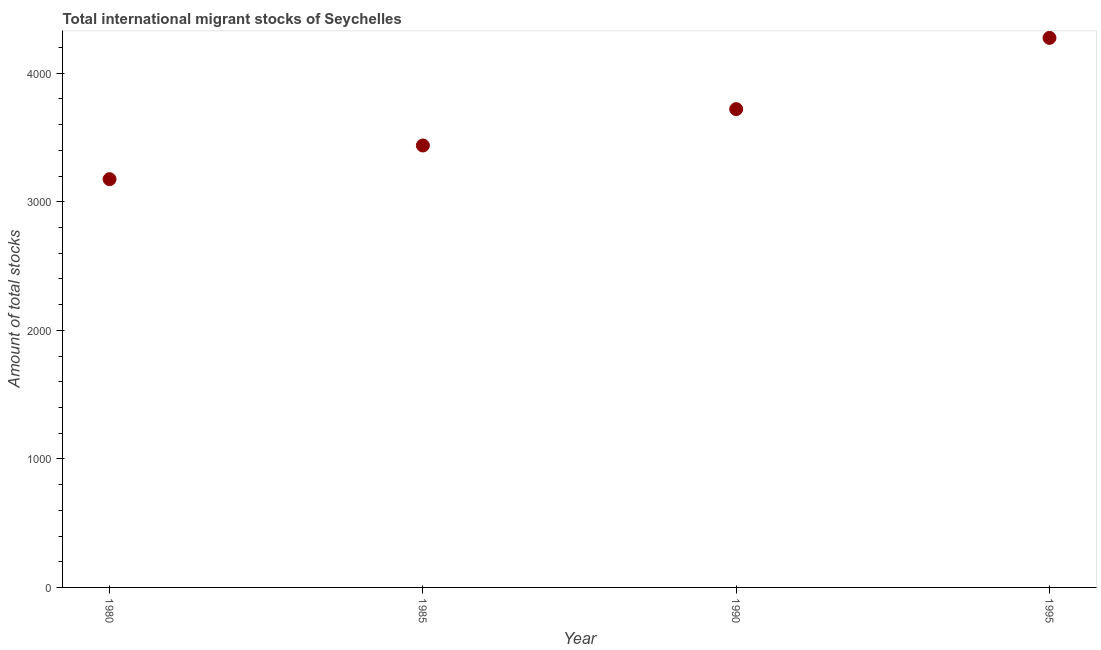What is the total number of international migrant stock in 1980?
Your response must be concise. 3176. Across all years, what is the maximum total number of international migrant stock?
Offer a terse response. 4275. Across all years, what is the minimum total number of international migrant stock?
Give a very brief answer. 3176. In which year was the total number of international migrant stock maximum?
Provide a succinct answer. 1995. What is the sum of the total number of international migrant stock?
Give a very brief answer. 1.46e+04. What is the difference between the total number of international migrant stock in 1980 and 1995?
Provide a short and direct response. -1099. What is the average total number of international migrant stock per year?
Offer a very short reply. 3652.5. What is the median total number of international migrant stock?
Ensure brevity in your answer.  3579.5. In how many years, is the total number of international migrant stock greater than 1200 ?
Ensure brevity in your answer.  4. What is the ratio of the total number of international migrant stock in 1985 to that in 1990?
Your answer should be very brief. 0.92. What is the difference between the highest and the second highest total number of international migrant stock?
Your answer should be very brief. 554. What is the difference between the highest and the lowest total number of international migrant stock?
Your answer should be very brief. 1099. In how many years, is the total number of international migrant stock greater than the average total number of international migrant stock taken over all years?
Your answer should be compact. 2. How many years are there in the graph?
Offer a very short reply. 4. What is the difference between two consecutive major ticks on the Y-axis?
Provide a short and direct response. 1000. Are the values on the major ticks of Y-axis written in scientific E-notation?
Make the answer very short. No. Does the graph contain any zero values?
Your answer should be very brief. No. What is the title of the graph?
Provide a short and direct response. Total international migrant stocks of Seychelles. What is the label or title of the Y-axis?
Your response must be concise. Amount of total stocks. What is the Amount of total stocks in 1980?
Provide a short and direct response. 3176. What is the Amount of total stocks in 1985?
Make the answer very short. 3438. What is the Amount of total stocks in 1990?
Make the answer very short. 3721. What is the Amount of total stocks in 1995?
Provide a short and direct response. 4275. What is the difference between the Amount of total stocks in 1980 and 1985?
Offer a terse response. -262. What is the difference between the Amount of total stocks in 1980 and 1990?
Provide a short and direct response. -545. What is the difference between the Amount of total stocks in 1980 and 1995?
Ensure brevity in your answer.  -1099. What is the difference between the Amount of total stocks in 1985 and 1990?
Your answer should be very brief. -283. What is the difference between the Amount of total stocks in 1985 and 1995?
Offer a very short reply. -837. What is the difference between the Amount of total stocks in 1990 and 1995?
Provide a short and direct response. -554. What is the ratio of the Amount of total stocks in 1980 to that in 1985?
Your response must be concise. 0.92. What is the ratio of the Amount of total stocks in 1980 to that in 1990?
Provide a short and direct response. 0.85. What is the ratio of the Amount of total stocks in 1980 to that in 1995?
Offer a very short reply. 0.74. What is the ratio of the Amount of total stocks in 1985 to that in 1990?
Give a very brief answer. 0.92. What is the ratio of the Amount of total stocks in 1985 to that in 1995?
Your answer should be compact. 0.8. What is the ratio of the Amount of total stocks in 1990 to that in 1995?
Your answer should be compact. 0.87. 